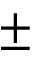Convert formula to latex. <formula><loc_0><loc_0><loc_500><loc_500>\pm</formula> 